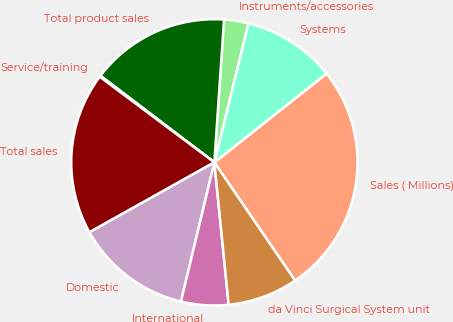<chart> <loc_0><loc_0><loc_500><loc_500><pie_chart><fcel>Sales ( Millions)<fcel>Systems<fcel>Instruments/accessories<fcel>Total product sales<fcel>Service/training<fcel>Total sales<fcel>Domestic<fcel>International<fcel>da Vinci Surgical System unit<nl><fcel>26.12%<fcel>10.53%<fcel>2.74%<fcel>15.73%<fcel>0.14%<fcel>18.33%<fcel>13.13%<fcel>5.34%<fcel>7.94%<nl></chart> 